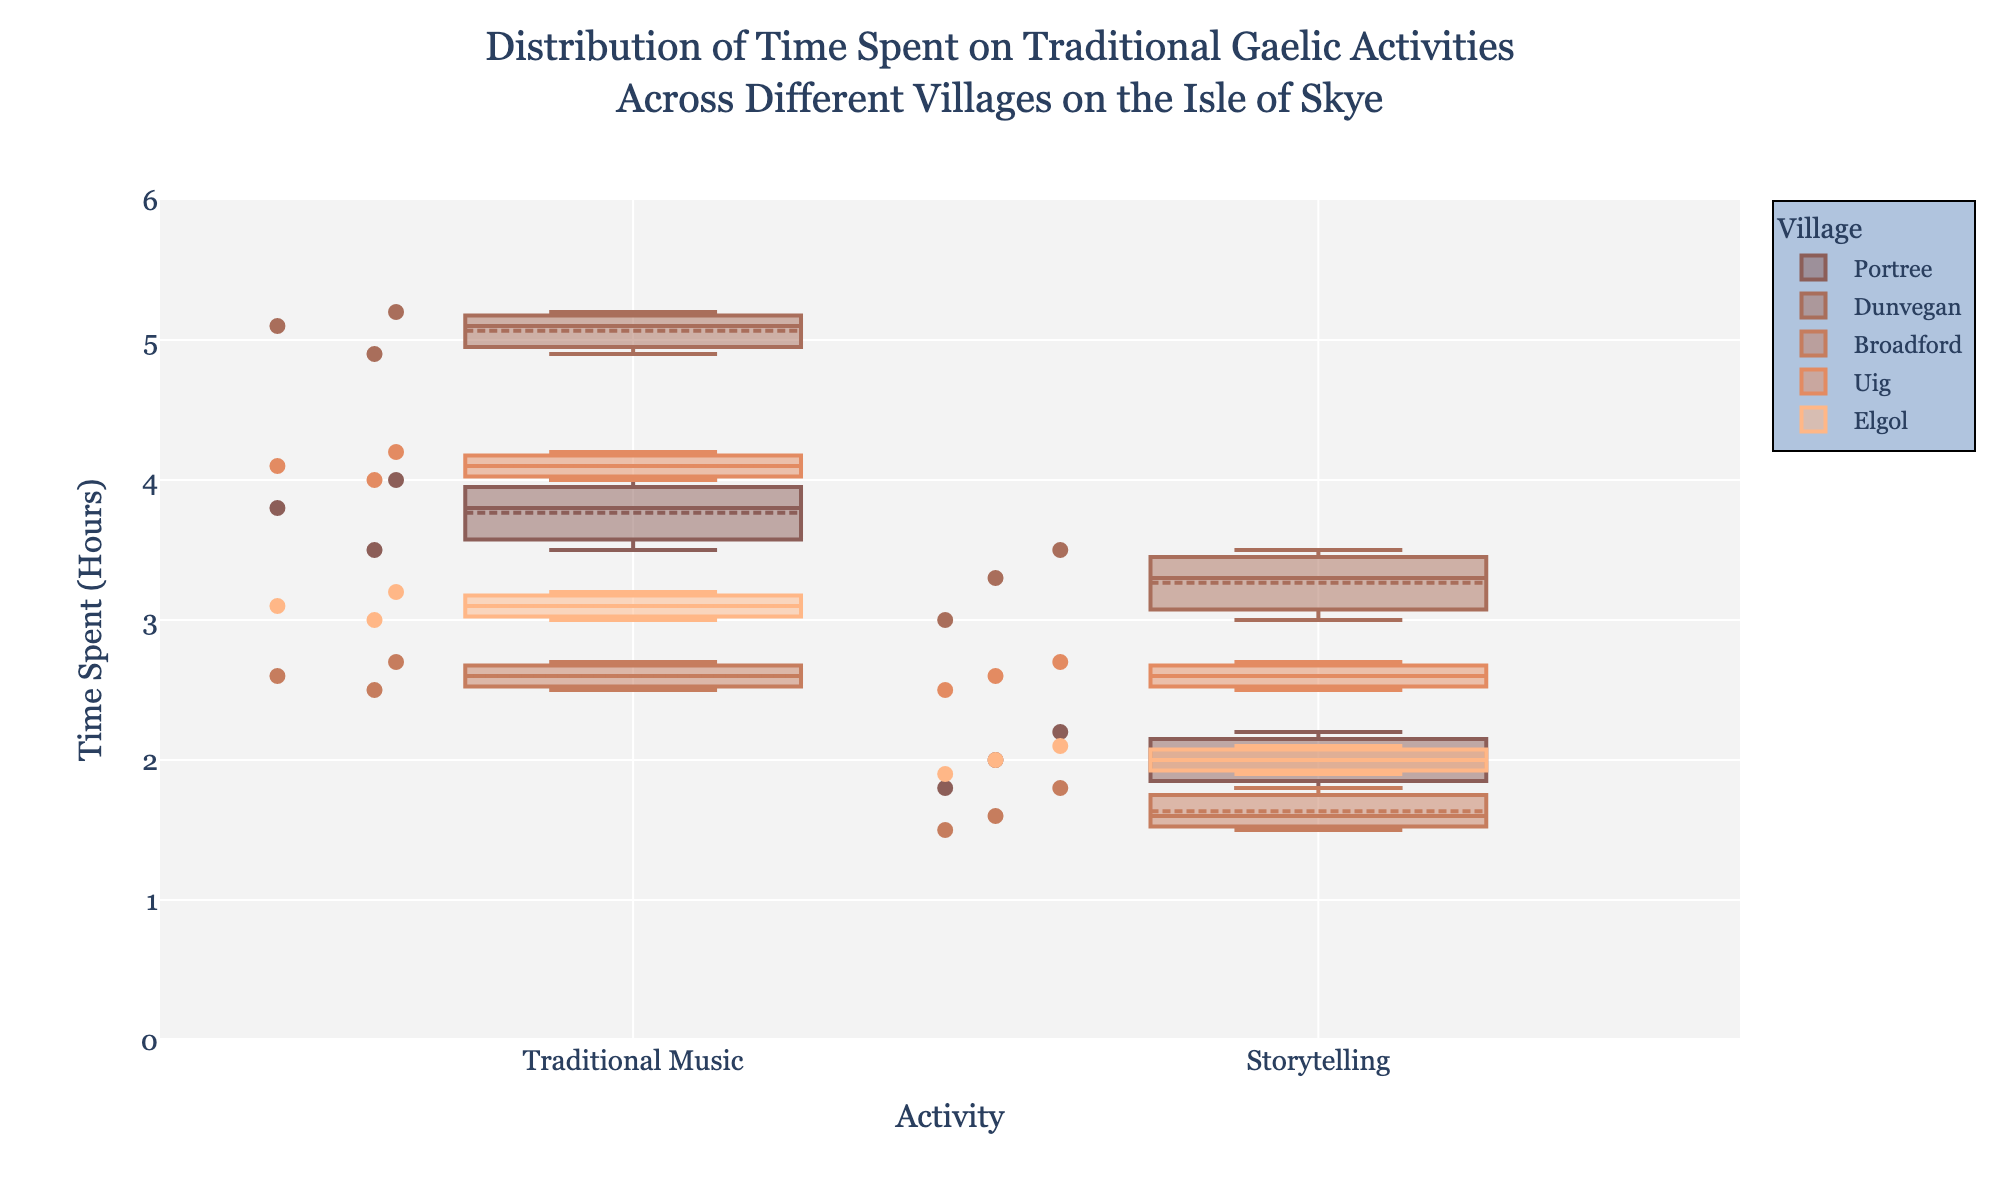what is the title of the plot? The title is located at the top of the plot. It generally provides a brief summary of what the plot represents.
Answer: Distribution of Time Spent on Traditional Gaelic Activities Across Different Villages on the Isle of Skye How many activities are represented in the plot? By examining the x-axis labels, which are typically used to represent different categories or activities, we can determine the number of activities.
Answer: 2 Which village has the highest median time spent on Traditional Music? Each box plot includes a line that shows the median value. By comparing the median lines across the villages for Traditional Music, we can identify the highest one.
Answer: Dunvegan Compare the average time spent on Storytelling between Portree and Dunvegan. We need to visually estimate or identify the mean values, which are often indicated by markers within the box plots for each village's Storytelling category. Then, compare these two mean values.
Answer: Portree has a lower average time spent compared to Dunvegan What is the range of time spent on Storytelling in Broadford? The range can be found by identifying the minimum and maximum values within the box plot for Storytelling in Broadford and finding the difference between these values.
Answer: 1.5 - 1.8 (0.3) How do the variability in time spent on Traditional Music in Uig compare to that in Portree? Variability is often represented by the interquartile range (IQR), the length of the box in the box plot. Compare the lengths of the boxes for Traditional Music in Uig and Portree.
Answer: Uig shows less variability compared to Portree Which village appears to spend the least amount of time on average on storytelling? We compare the mean values marked in the box plots for Storytelling across all villages and identify the smallest one.
Answer: Broadford Identify the village with the widest spread of time spent on any activity. The spread of time is represented by the range (whiskers) of the box plots. Assess all box plots in the figure and identify the one with the widest spread.
Answer: Dunvegan (Traditional Music) How does the time spent on Traditional Music contrast with Storytelling in Elgol? Compare the central tendencies (medians and means) and spreads of the two activities within Elgol by looking at their respective box plots.
Answer: Time spent on Traditional Music is generally higher than Storytelling in Elgol Which village has the least difference in median time spent between Traditional Music and Storytelling? Examine the median lines within the box plots for both Traditional Music and Storytelling in each village and identify the smallest difference.
Answer: Elgol 